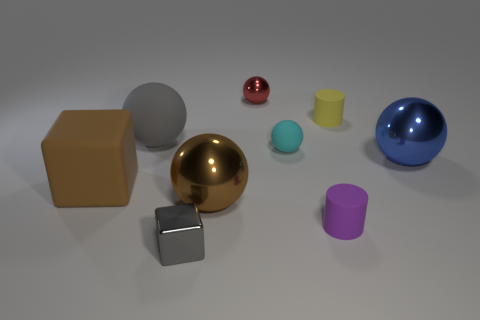There is a red metal sphere; are there any blocks behind it?
Provide a succinct answer. No. There is a big metal object behind the big brown thing that is in front of the large brown matte cube; what is its color?
Your answer should be very brief. Blue. Are there fewer blue spheres than gray things?
Ensure brevity in your answer.  Yes. How many gray matte objects are the same shape as the yellow object?
Your answer should be compact. 0. There is a cube that is the same size as the red shiny ball; what color is it?
Ensure brevity in your answer.  Gray. Is the number of tiny red metal things right of the small yellow cylinder the same as the number of rubber balls that are to the left of the gray rubber ball?
Provide a succinct answer. Yes. Is there another metal object that has the same size as the blue shiny thing?
Offer a terse response. Yes. How big is the matte block?
Ensure brevity in your answer.  Large. Is the number of brown things that are left of the big brown block the same as the number of yellow balls?
Make the answer very short. Yes. How many other objects are the same color as the big matte ball?
Offer a terse response. 1. 